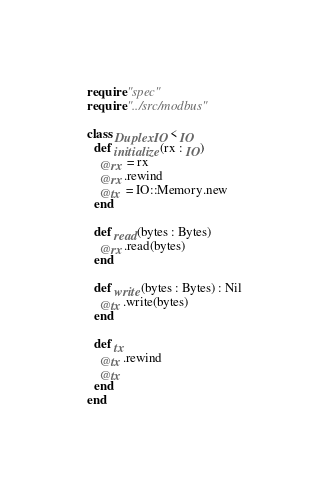Convert code to text. <code><loc_0><loc_0><loc_500><loc_500><_Crystal_>require "spec"
require "../src/modbus"

class DuplexIO < IO
  def initialize(rx : IO)
    @rx = rx
    @rx.rewind
    @tx = IO::Memory.new
  end

  def read(bytes : Bytes)
    @rx.read(bytes)
  end

  def write(bytes : Bytes) : Nil
    @tx.write(bytes)
  end

  def tx
    @tx.rewind
    @tx
  end
end
</code> 